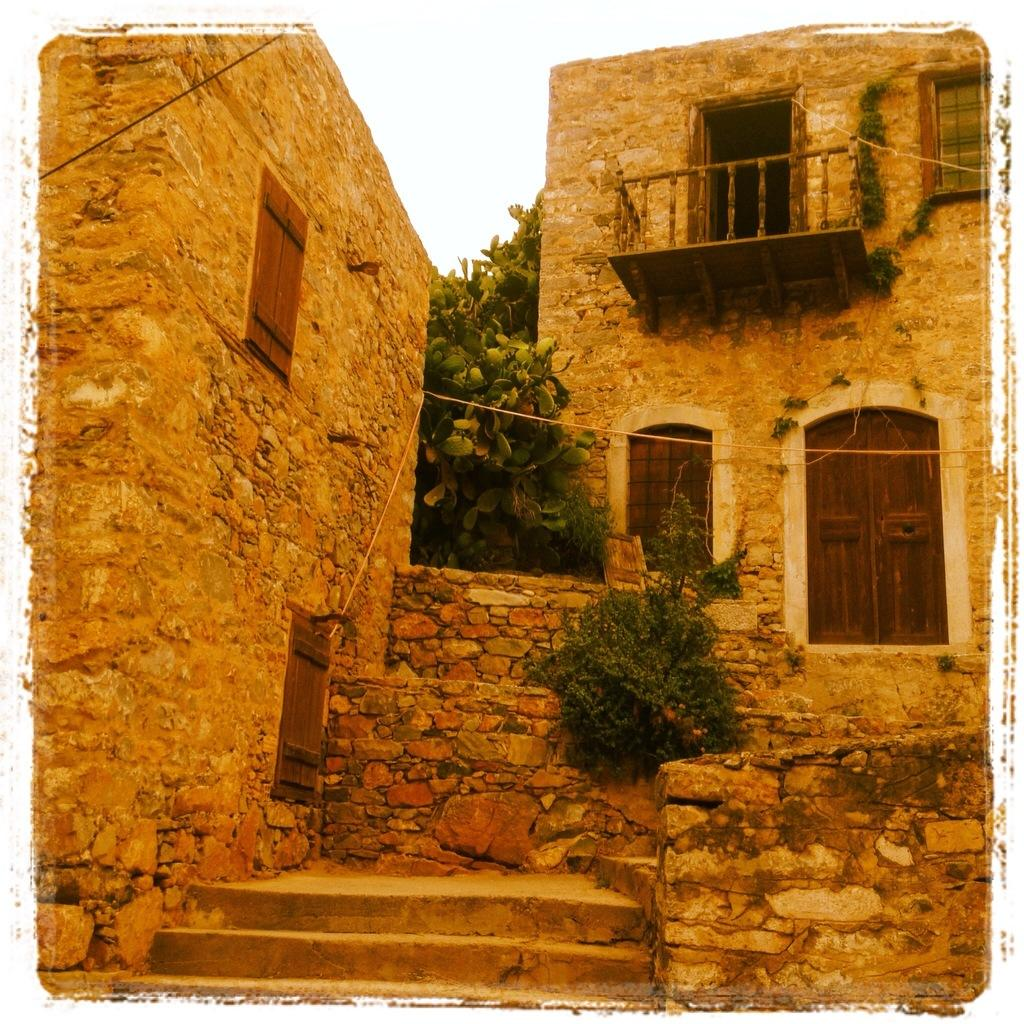What type of house is in the middle of the image? There is a stone house in the middle of the image. Where is the door located on the house? The door is on the right side of the house. What else can be seen in the middle of the image besides the house? There are plants in the middle of the image. What is visible at the top of the image? The sky is visible at the top of the image. What architectural feature is present at the bottom of the image? There are steps at the bottom of the image. What type of drum can be heard playing in the background of the image? There is no drum or sound present in the image; it is a static picture of a stone house, plants, and steps. 